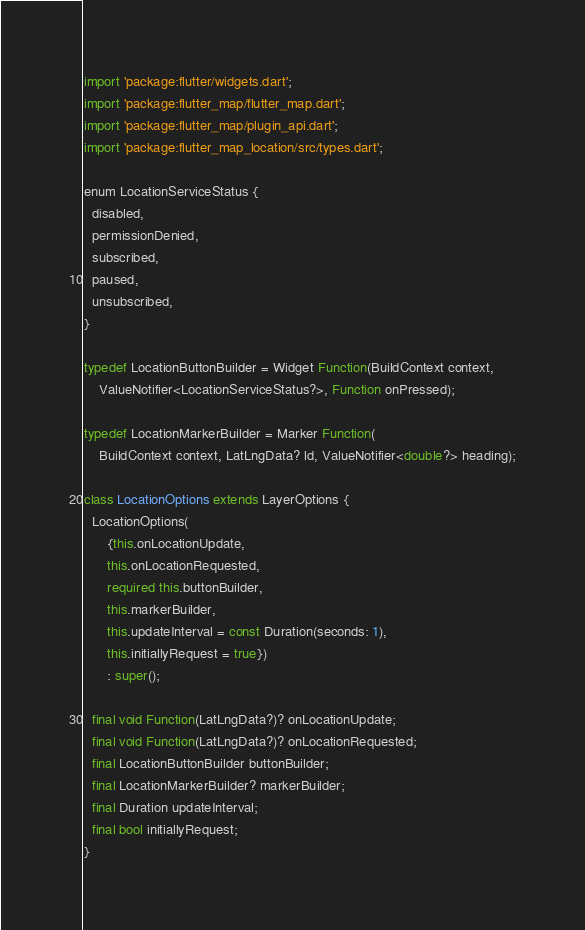Convert code to text. <code><loc_0><loc_0><loc_500><loc_500><_Dart_>import 'package:flutter/widgets.dart';
import 'package:flutter_map/flutter_map.dart';
import 'package:flutter_map/plugin_api.dart';
import 'package:flutter_map_location/src/types.dart';

enum LocationServiceStatus {
  disabled,
  permissionDenied,
  subscribed,
  paused,
  unsubscribed,
}

typedef LocationButtonBuilder = Widget Function(BuildContext context,
    ValueNotifier<LocationServiceStatus?>, Function onPressed);

typedef LocationMarkerBuilder = Marker Function(
    BuildContext context, LatLngData? ld, ValueNotifier<double?> heading);

class LocationOptions extends LayerOptions {
  LocationOptions(
      {this.onLocationUpdate,
      this.onLocationRequested,
      required this.buttonBuilder,
      this.markerBuilder,
      this.updateInterval = const Duration(seconds: 1),
      this.initiallyRequest = true})
      : super();

  final void Function(LatLngData?)? onLocationUpdate;
  final void Function(LatLngData?)? onLocationRequested;
  final LocationButtonBuilder buttonBuilder;
  final LocationMarkerBuilder? markerBuilder;
  final Duration updateInterval;
  final bool initiallyRequest;
}
</code> 